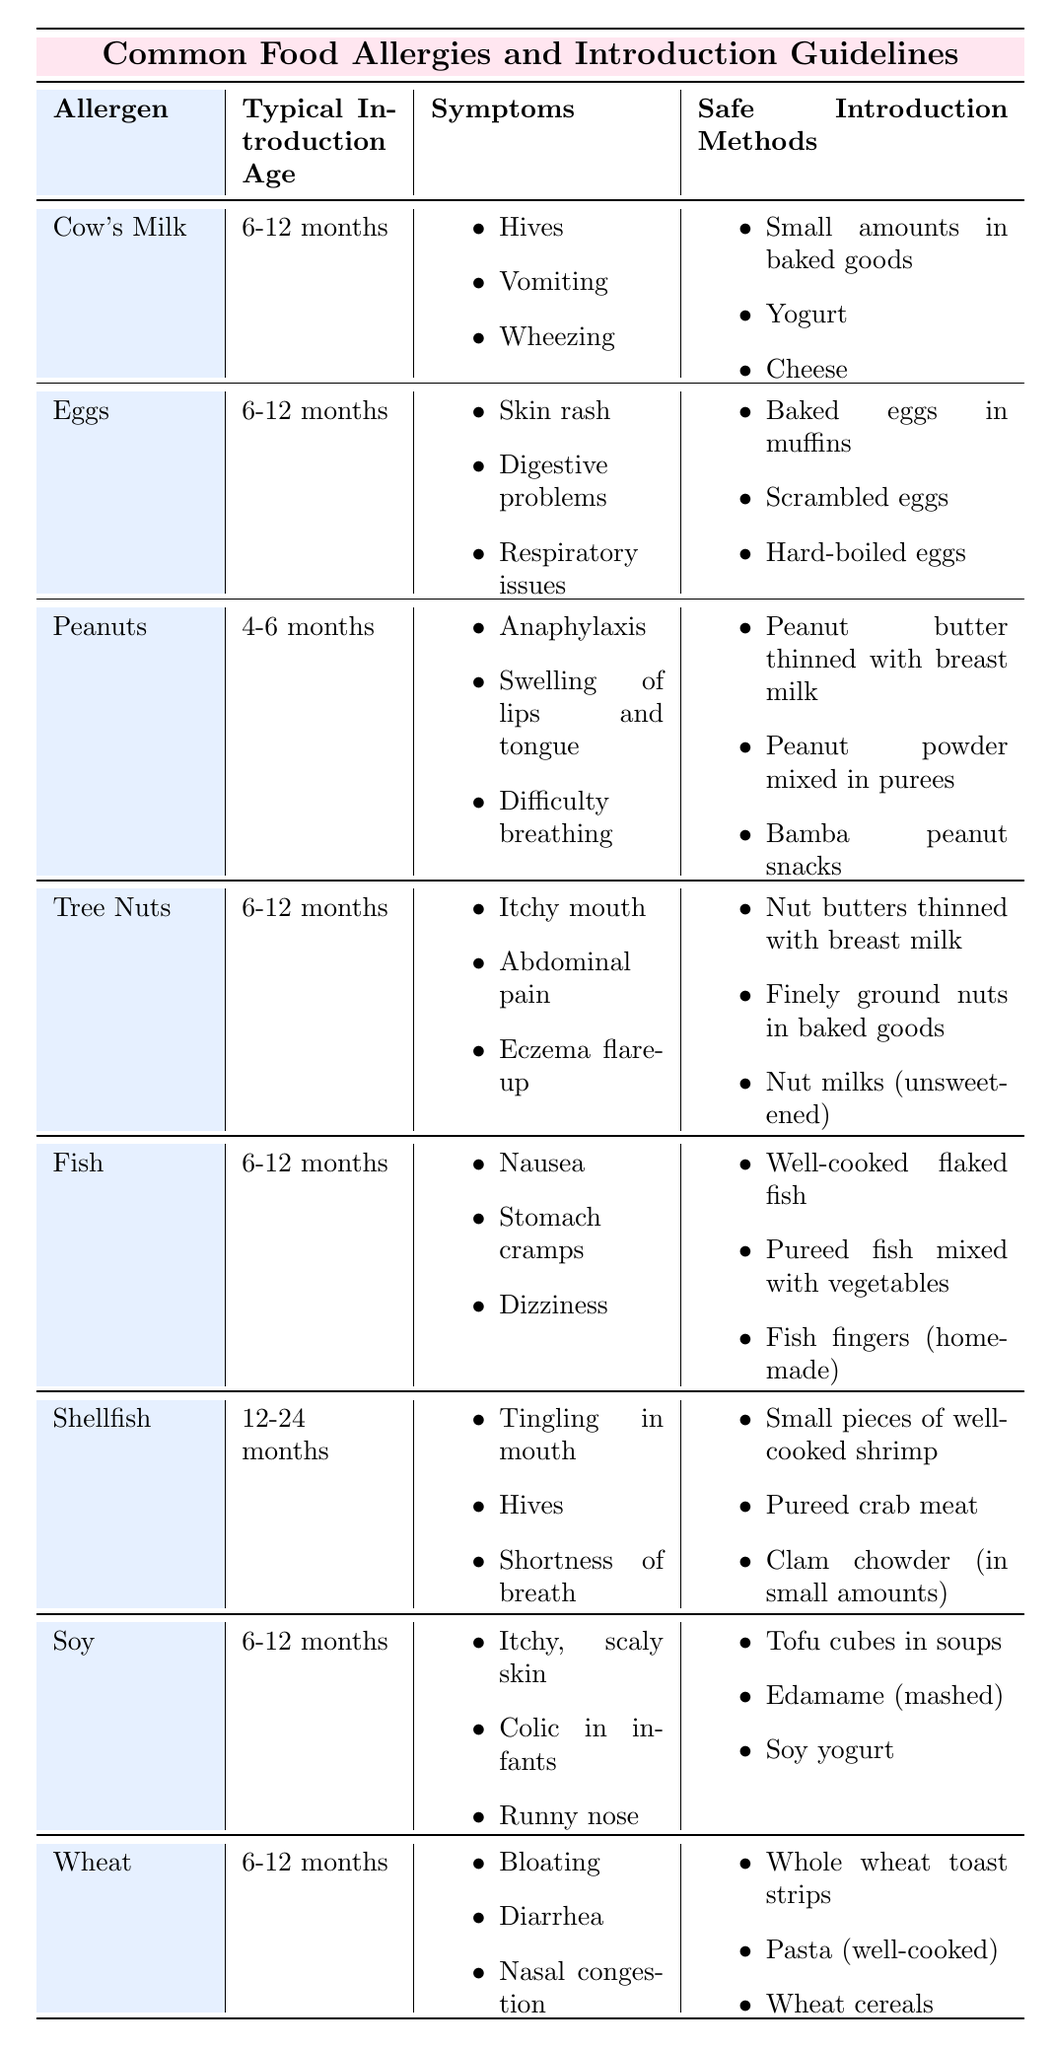What is the typical introduction age for peanuts? In the table, under the "Typical Introduction Age" column for peanuts, it states that the age is 4-6 months.
Answer: 4-6 months How many allergens are safe to introduce at 6-12 months? By counting the allergens listed with a typical introduction age of 6-12 months, we find a total of 5: Cow's Milk, Eggs, Tree Nuts, Fish, Soy, and Wheat.
Answer: 5 Do eggs have symptoms that include skin rash? Looking at the symptoms listed for eggs, it includes "Skin rash," thus this statement is true.
Answer: Yes Which allergen has the earliest typical introduction age? By comparing the typical introduction ages in the table, peanuts have the earliest age of 4-6 months.
Answer: Peanuts What is the safe introduction method for cow's milk? The table lists three safe introduction methods for cow's milk: Small amounts in baked goods, Yogurt, and Cheese.
Answer: Small amounts in baked goods, Yogurt, Cheese What is the difference in introduction age between tree nuts and shellfish? Tree nuts are introduced at 6-12 months and shellfish at 12-24 months, so the difference is 6-12 months.
Answer: 6-12 months Can you identify which allergen has both hives and dizziness as symptoms? From the table, cow's milk has hives and fish has dizziness. The only allergen that has both symptoms is cow's milk.
Answer: Cow's Milk What percentage of the allergens listed can be introduced before 12 months? There are 7 allergens in total, 6 of which can be introduced before 12 months (Cow's Milk, Eggs, Peanuts, Tree Nuts, Fish, and Soy), thus the percentage is (6/7) * 100 = approximately 85.71%.
Answer: 85.71% What are the symptoms associated with the introduction of wheat? For wheat, the symptoms listed are: Bloating, Diarrhea, and Nasal congestion.
Answer: Bloating, Diarrhea, Nasal congestion Which allergen has the symptom of anaphylaxis? The allergen that lists "Anaphylaxis" as a symptom is peanuts.
Answer: Peanuts 